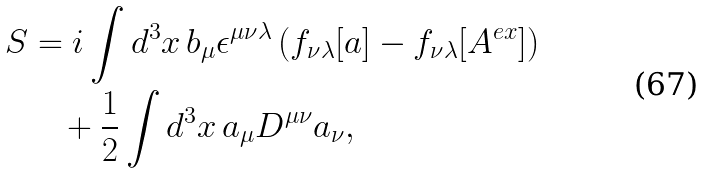Convert formula to latex. <formula><loc_0><loc_0><loc_500><loc_500>S & = i \int d ^ { 3 } x \, b _ { \mu } \epsilon ^ { \mu \nu \lambda } \left ( f _ { \nu \lambda } [ a ] - f _ { \nu \lambda } [ A ^ { e x } ] \right ) \\ & \quad + \frac { 1 } { 2 } \int d ^ { 3 } x \, a _ { \mu } D ^ { \mu \nu } a _ { \nu } ,</formula> 